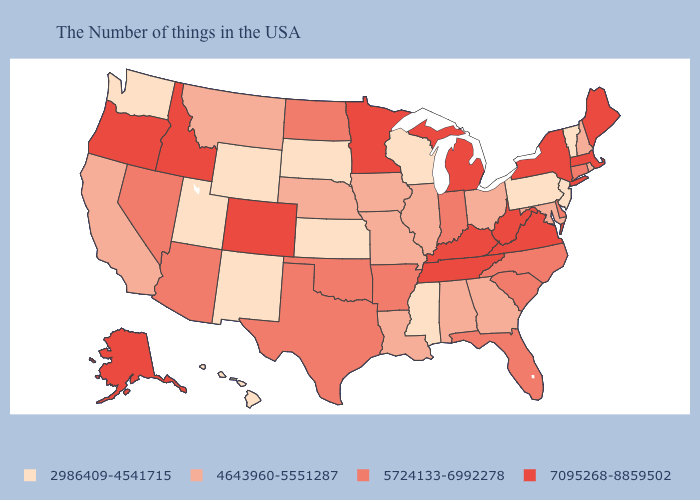Name the states that have a value in the range 4643960-5551287?
Give a very brief answer. Rhode Island, New Hampshire, Maryland, Ohio, Georgia, Alabama, Illinois, Louisiana, Missouri, Iowa, Nebraska, Montana, California. Among the states that border Alabama , does Tennessee have the highest value?
Quick response, please. Yes. What is the value of Wyoming?
Concise answer only. 2986409-4541715. Which states hav the highest value in the Northeast?
Give a very brief answer. Maine, Massachusetts, New York. What is the highest value in the South ?
Short answer required. 7095268-8859502. Name the states that have a value in the range 7095268-8859502?
Give a very brief answer. Maine, Massachusetts, New York, Virginia, West Virginia, Michigan, Kentucky, Tennessee, Minnesota, Colorado, Idaho, Oregon, Alaska. What is the value of Alabama?
Be succinct. 4643960-5551287. Which states have the highest value in the USA?
Be succinct. Maine, Massachusetts, New York, Virginia, West Virginia, Michigan, Kentucky, Tennessee, Minnesota, Colorado, Idaho, Oregon, Alaska. What is the value of Washington?
Short answer required. 2986409-4541715. What is the highest value in the USA?
Write a very short answer. 7095268-8859502. Name the states that have a value in the range 5724133-6992278?
Be succinct. Connecticut, Delaware, North Carolina, South Carolina, Florida, Indiana, Arkansas, Oklahoma, Texas, North Dakota, Arizona, Nevada. How many symbols are there in the legend?
Answer briefly. 4. Does California have a lower value than Delaware?
Quick response, please. Yes. Name the states that have a value in the range 7095268-8859502?
Be succinct. Maine, Massachusetts, New York, Virginia, West Virginia, Michigan, Kentucky, Tennessee, Minnesota, Colorado, Idaho, Oregon, Alaska. Does West Virginia have the lowest value in the USA?
Give a very brief answer. No. 